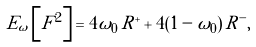<formula> <loc_0><loc_0><loc_500><loc_500>E _ { \omega } \left [ F ^ { 2 } \right ] = 4 \omega _ { 0 } \, R ^ { + } + 4 ( 1 - \omega _ { 0 } ) \, R ^ { - } ,</formula> 